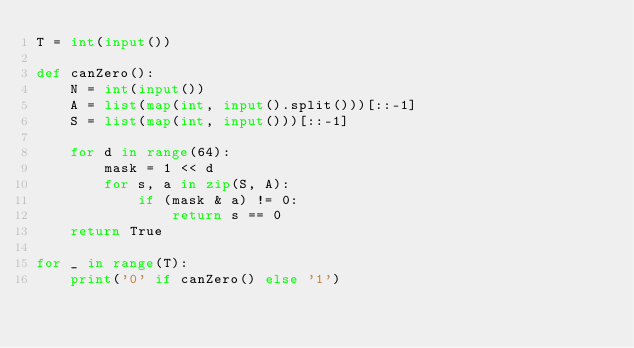Convert code to text. <code><loc_0><loc_0><loc_500><loc_500><_Python_>T = int(input())

def canZero():
    N = int(input())
    A = list(map(int, input().split()))[::-1]
    S = list(map(int, input()))[::-1]

    for d in range(64):
        mask = 1 << d
        for s, a in zip(S, A):
            if (mask & a) != 0:
                return s == 0
    return True

for _ in range(T):
    print('0' if canZero() else '1')
</code> 